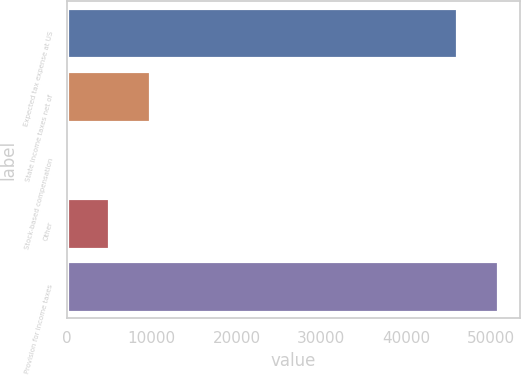<chart> <loc_0><loc_0><loc_500><loc_500><bar_chart><fcel>Expected tax expense at US<fcel>State income taxes net of<fcel>Stock-based compensation<fcel>Other<fcel>Provision for income taxes<nl><fcel>46060<fcel>9781.2<fcel>108<fcel>4944.6<fcel>50896.6<nl></chart> 